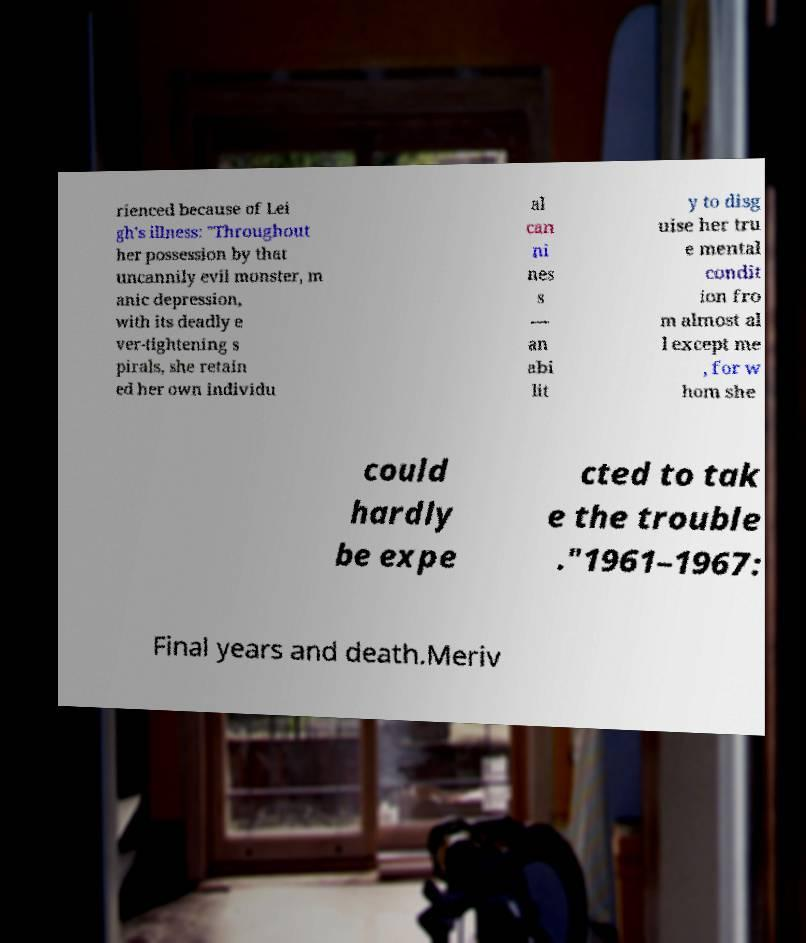For documentation purposes, I need the text within this image transcribed. Could you provide that? rienced because of Lei gh's illness: "Throughout her possession by that uncannily evil monster, m anic depression, with its deadly e ver-tightening s pirals, she retain ed her own individu al can ni nes s — an abi lit y to disg uise her tru e mental condit ion fro m almost al l except me , for w hom she could hardly be expe cted to tak e the trouble ."1961–1967: Final years and death.Meriv 